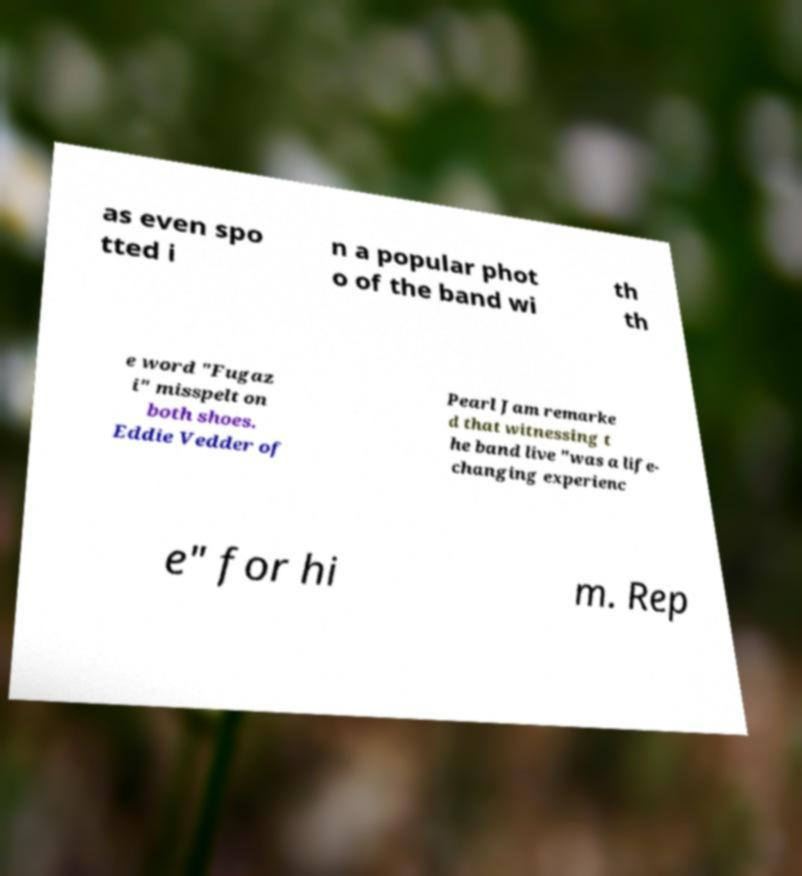Can you accurately transcribe the text from the provided image for me? as even spo tted i n a popular phot o of the band wi th th e word "Fugaz i" misspelt on both shoes. Eddie Vedder of Pearl Jam remarke d that witnessing t he band live "was a life- changing experienc e" for hi m. Rep 